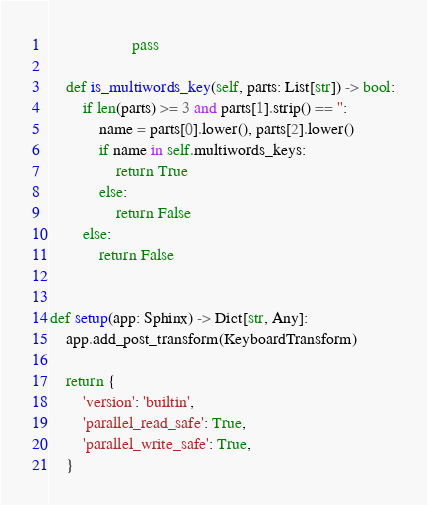<code> <loc_0><loc_0><loc_500><loc_500><_Python_>                    pass

    def is_multiwords_key(self, parts: List[str]) -> bool:
        if len(parts) >= 3 and parts[1].strip() == '':
            name = parts[0].lower(), parts[2].lower()
            if name in self.multiwords_keys:
                return True
            else:
                return False
        else:
            return False


def setup(app: Sphinx) -> Dict[str, Any]:
    app.add_post_transform(KeyboardTransform)

    return {
        'version': 'builtin',
        'parallel_read_safe': True,
        'parallel_write_safe': True,
    }
</code> 